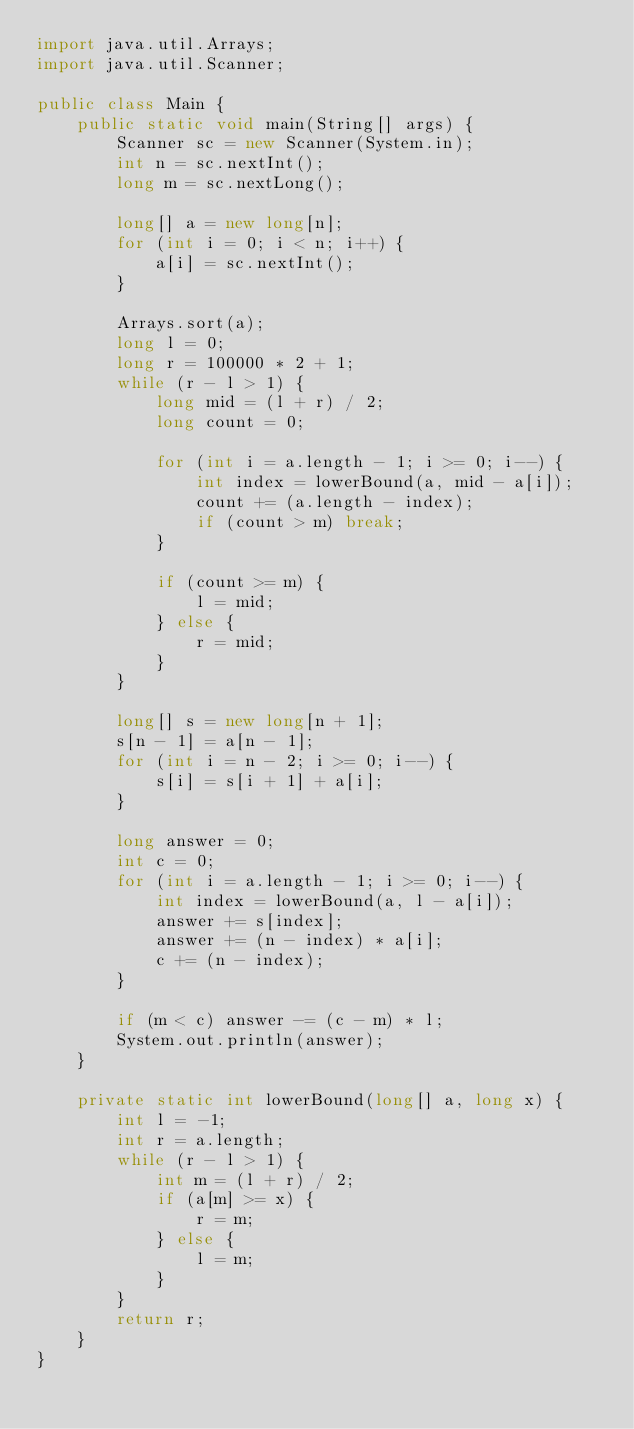Convert code to text. <code><loc_0><loc_0><loc_500><loc_500><_Java_>import java.util.Arrays;
import java.util.Scanner;

public class Main {
	public static void main(String[] args) {
		Scanner sc = new Scanner(System.in);
		int n = sc.nextInt();
		long m = sc.nextLong();

		long[] a = new long[n];
		for (int i = 0; i < n; i++) {
			a[i] = sc.nextInt();
		}

		Arrays.sort(a);
		long l = 0;
		long r = 100000 * 2 + 1;
		while (r - l > 1) {
			long mid = (l + r) / 2;
			long count = 0;

			for (int i = a.length - 1; i >= 0; i--) {
				int index = lowerBound(a, mid - a[i]);
				count += (a.length - index);
				if (count > m) break;
			}

			if (count >= m) {
				l = mid;
			} else {
				r = mid;
			}
		}

		long[] s = new long[n + 1];
		s[n - 1] = a[n - 1];
		for (int i = n - 2; i >= 0; i--) {
			s[i] = s[i + 1] + a[i];
		}

		long answer = 0;
		int c = 0;
		for (int i = a.length - 1; i >= 0; i--) {
			int index = lowerBound(a, l - a[i]);
			answer += s[index];
			answer += (n - index) * a[i];
			c += (n - index);
		}

		if (m < c) answer -= (c - m) * l;
		System.out.println(answer);
	}

	private static int lowerBound(long[] a, long x) {
		int l = -1;
		int r = a.length;
		while (r - l > 1) {
			int m = (l + r) / 2;
			if (a[m] >= x) {
				r = m;
			} else {
				l = m;
			}
		}
		return r;
	}
}
</code> 